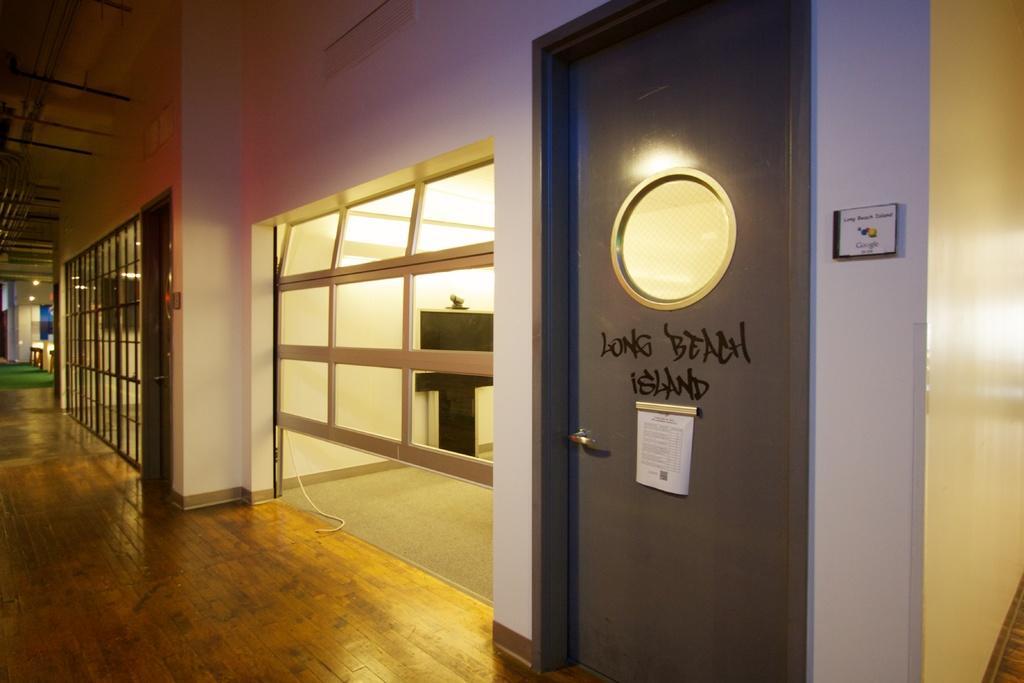In one or two sentences, can you explain what this image depicts? In the foreground of this image, on the right there is a door, few boards and the glass wall. At the top, there is wall and the ceiling. In the background, there is glass wall, few lights, objects and the green carpet. 